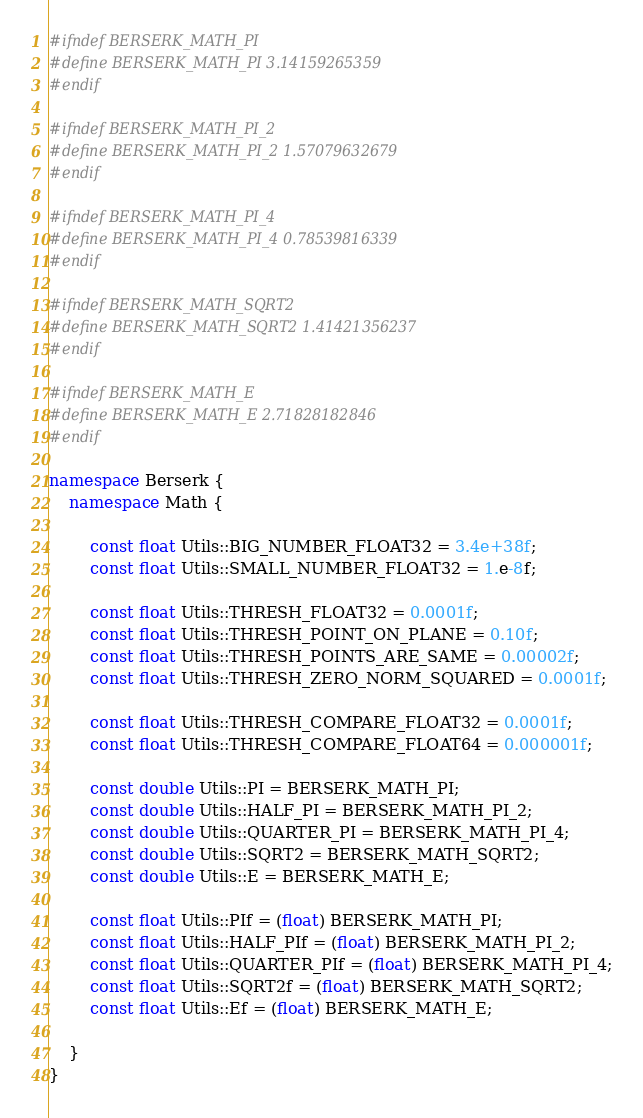Convert code to text. <code><loc_0><loc_0><loc_500><loc_500><_C++_>
#ifndef BERSERK_MATH_PI
#define BERSERK_MATH_PI 3.14159265359
#endif

#ifndef BERSERK_MATH_PI_2
#define BERSERK_MATH_PI_2 1.57079632679
#endif

#ifndef BERSERK_MATH_PI_4
#define BERSERK_MATH_PI_4 0.78539816339
#endif

#ifndef BERSERK_MATH_SQRT2
#define BERSERK_MATH_SQRT2 1.41421356237
#endif

#ifndef BERSERK_MATH_E
#define BERSERK_MATH_E 2.71828182846
#endif

namespace Berserk {
    namespace Math {

        const float Utils::BIG_NUMBER_FLOAT32 = 3.4e+38f;
        const float Utils::SMALL_NUMBER_FLOAT32 = 1.e-8f;

        const float Utils::THRESH_FLOAT32 = 0.0001f;
        const float Utils::THRESH_POINT_ON_PLANE = 0.10f;
        const float Utils::THRESH_POINTS_ARE_SAME = 0.00002f;
        const float Utils::THRESH_ZERO_NORM_SQUARED = 0.0001f;

        const float Utils::THRESH_COMPARE_FLOAT32 = 0.0001f;
        const float Utils::THRESH_COMPARE_FLOAT64 = 0.000001f;

        const double Utils::PI = BERSERK_MATH_PI;
        const double Utils::HALF_PI = BERSERK_MATH_PI_2;
        const double Utils::QUARTER_PI = BERSERK_MATH_PI_4;
        const double Utils::SQRT2 = BERSERK_MATH_SQRT2;
        const double Utils::E = BERSERK_MATH_E;

        const float Utils::PIf = (float) BERSERK_MATH_PI;
        const float Utils::HALF_PIf = (float) BERSERK_MATH_PI_2;
        const float Utils::QUARTER_PIf = (float) BERSERK_MATH_PI_4;
        const float Utils::SQRT2f = (float) BERSERK_MATH_SQRT2;
        const float Utils::Ef = (float) BERSERK_MATH_E;

    }
}</code> 